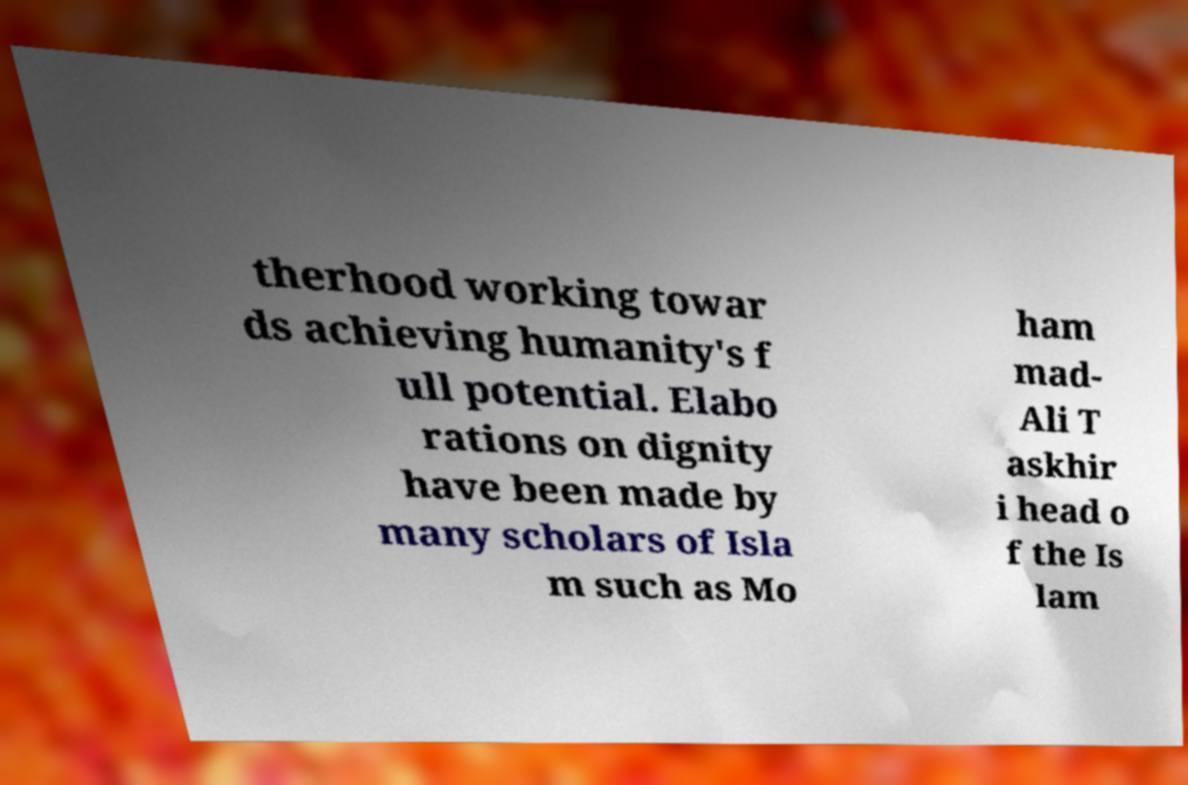There's text embedded in this image that I need extracted. Can you transcribe it verbatim? therhood working towar ds achieving humanity's f ull potential. Elabo rations on dignity have been made by many scholars of Isla m such as Mo ham mad- Ali T askhir i head o f the Is lam 